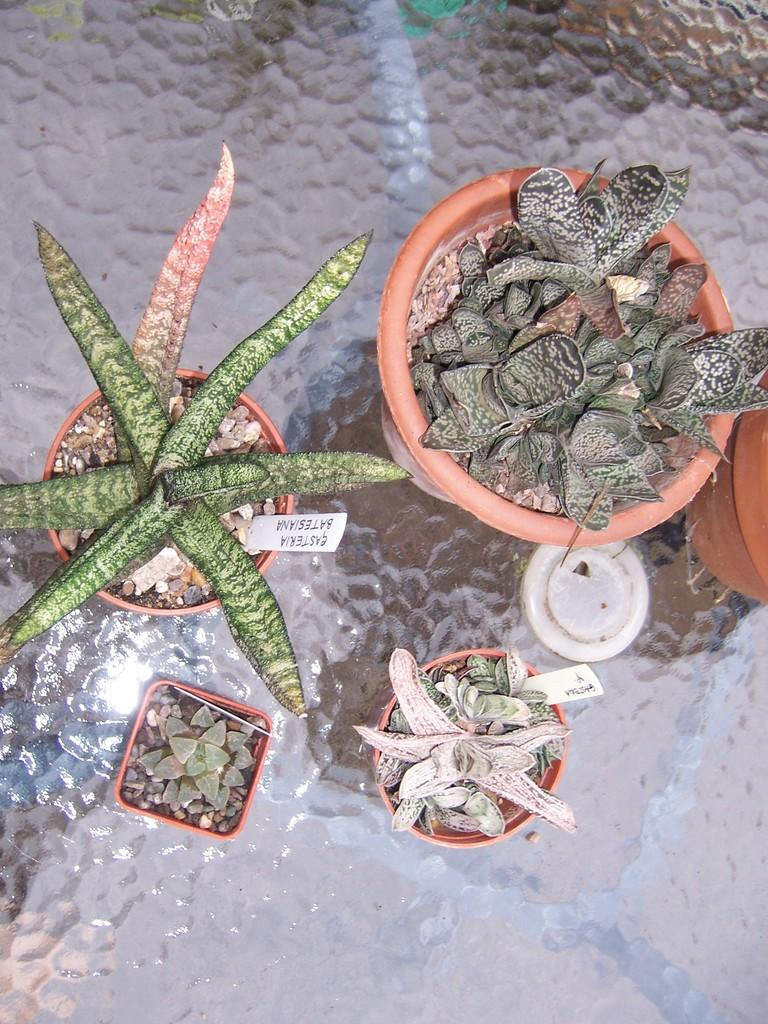What objects are visible in the image? There are flower pots in the image. Where are the flower pots located? The flower pots are placed on a glass table. How can you identify the specific flowers in each pot? Name tags are present in each flower pot. What type of locket can be seen hanging from the flower pots in the image? There is no locket present in the image; it only features flower pots with name tags on a glass table. 